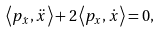<formula> <loc_0><loc_0><loc_500><loc_500>\left \langle p _ { \dot { x } } , \ddot { x } \right \rangle + 2 \left \langle p _ { x } , \dot { x } \right \rangle = 0 ,</formula> 